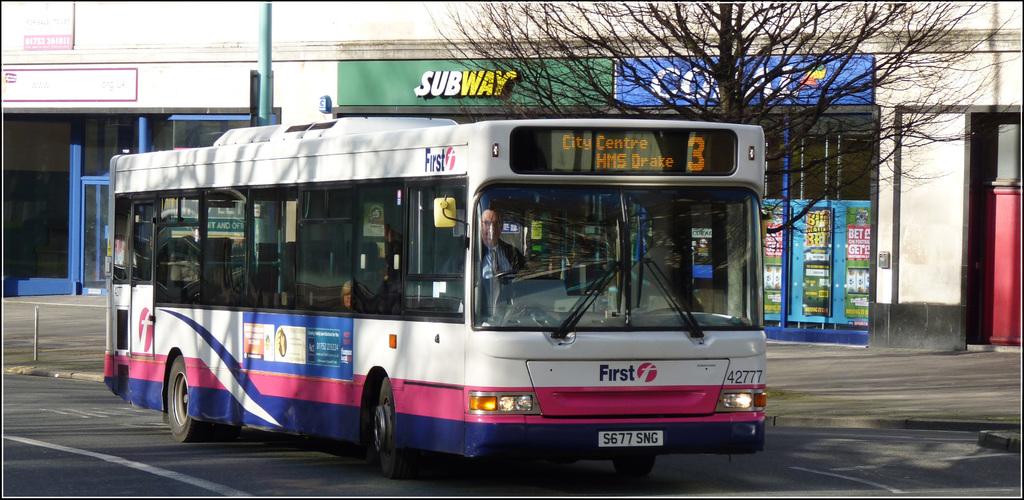Where is this bus going?
Keep it short and to the point. City centre. What brand is on the green sign behind?
Your response must be concise. Subway. 